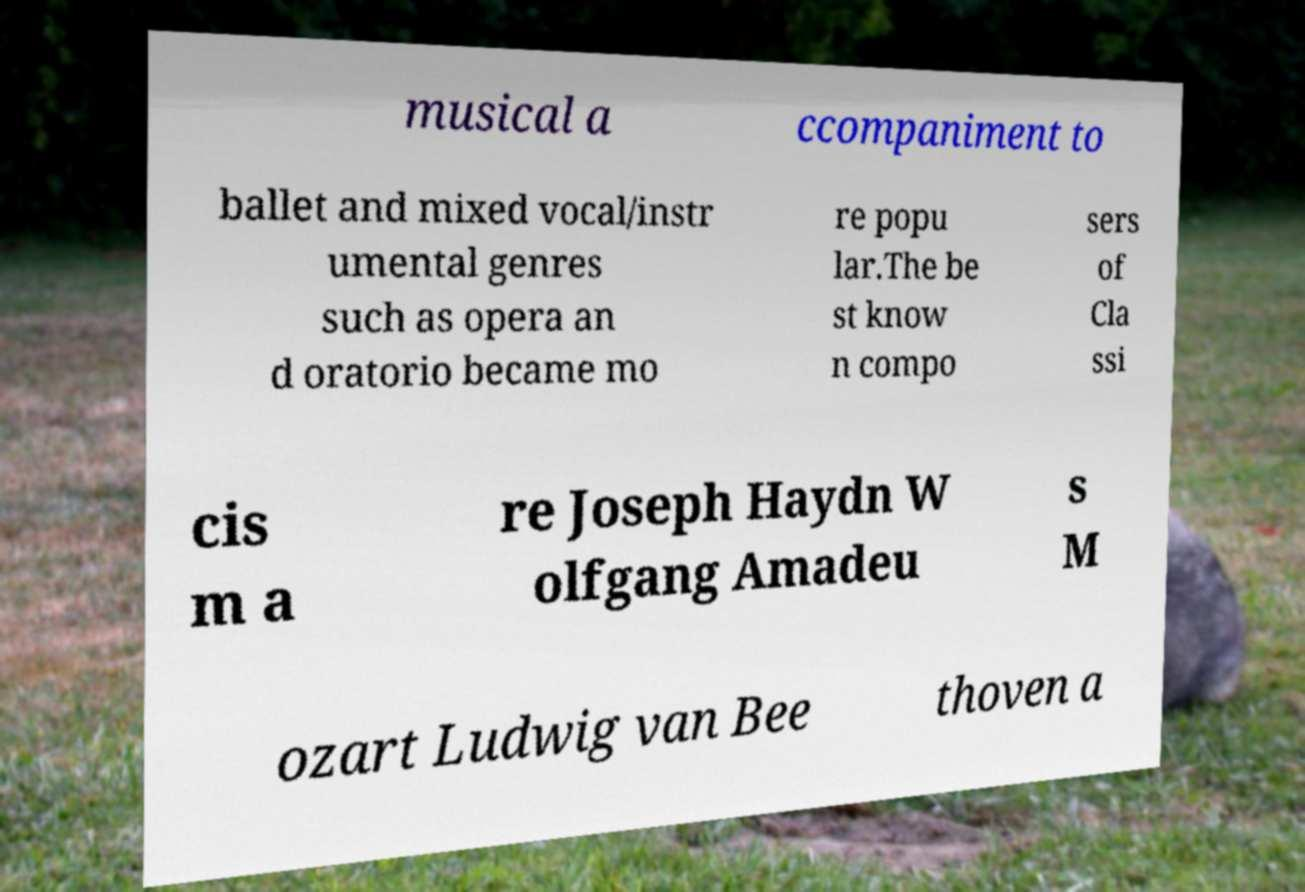Could you assist in decoding the text presented in this image and type it out clearly? musical a ccompaniment to ballet and mixed vocal/instr umental genres such as opera an d oratorio became mo re popu lar.The be st know n compo sers of Cla ssi cis m a re Joseph Haydn W olfgang Amadeu s M ozart Ludwig van Bee thoven a 